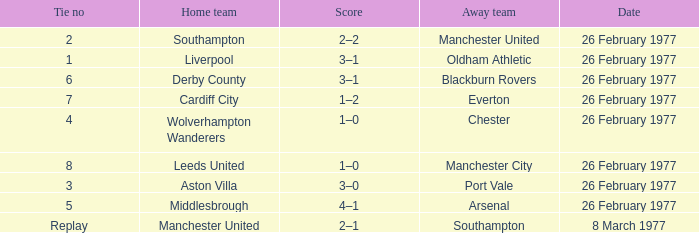What's the score when the tie number was replay? 2–1. 